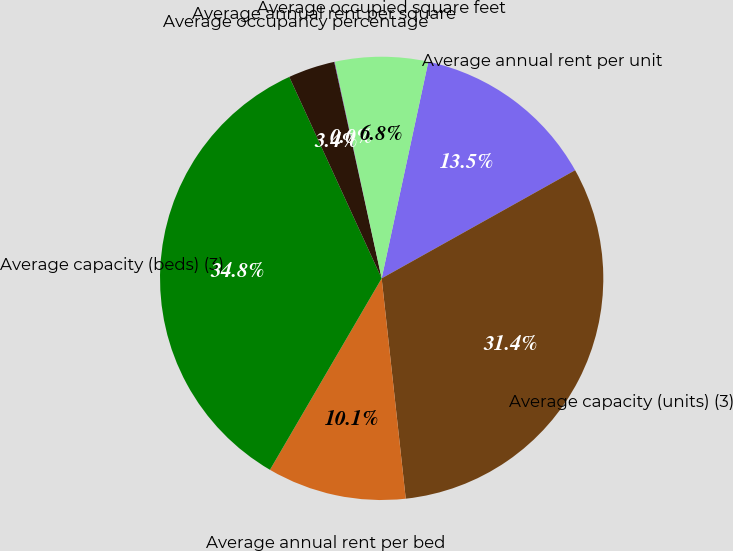Convert chart. <chart><loc_0><loc_0><loc_500><loc_500><pie_chart><fcel>Average annual rent per unit<fcel>Average capacity (units) (3)<fcel>Average annual rent per bed<fcel>Average capacity (beds) (3)<fcel>Average occupancy percentage<fcel>Average annual rent per square<fcel>Average occupied square feet<nl><fcel>13.51%<fcel>31.38%<fcel>10.14%<fcel>34.75%<fcel>3.41%<fcel>0.04%<fcel>6.77%<nl></chart> 